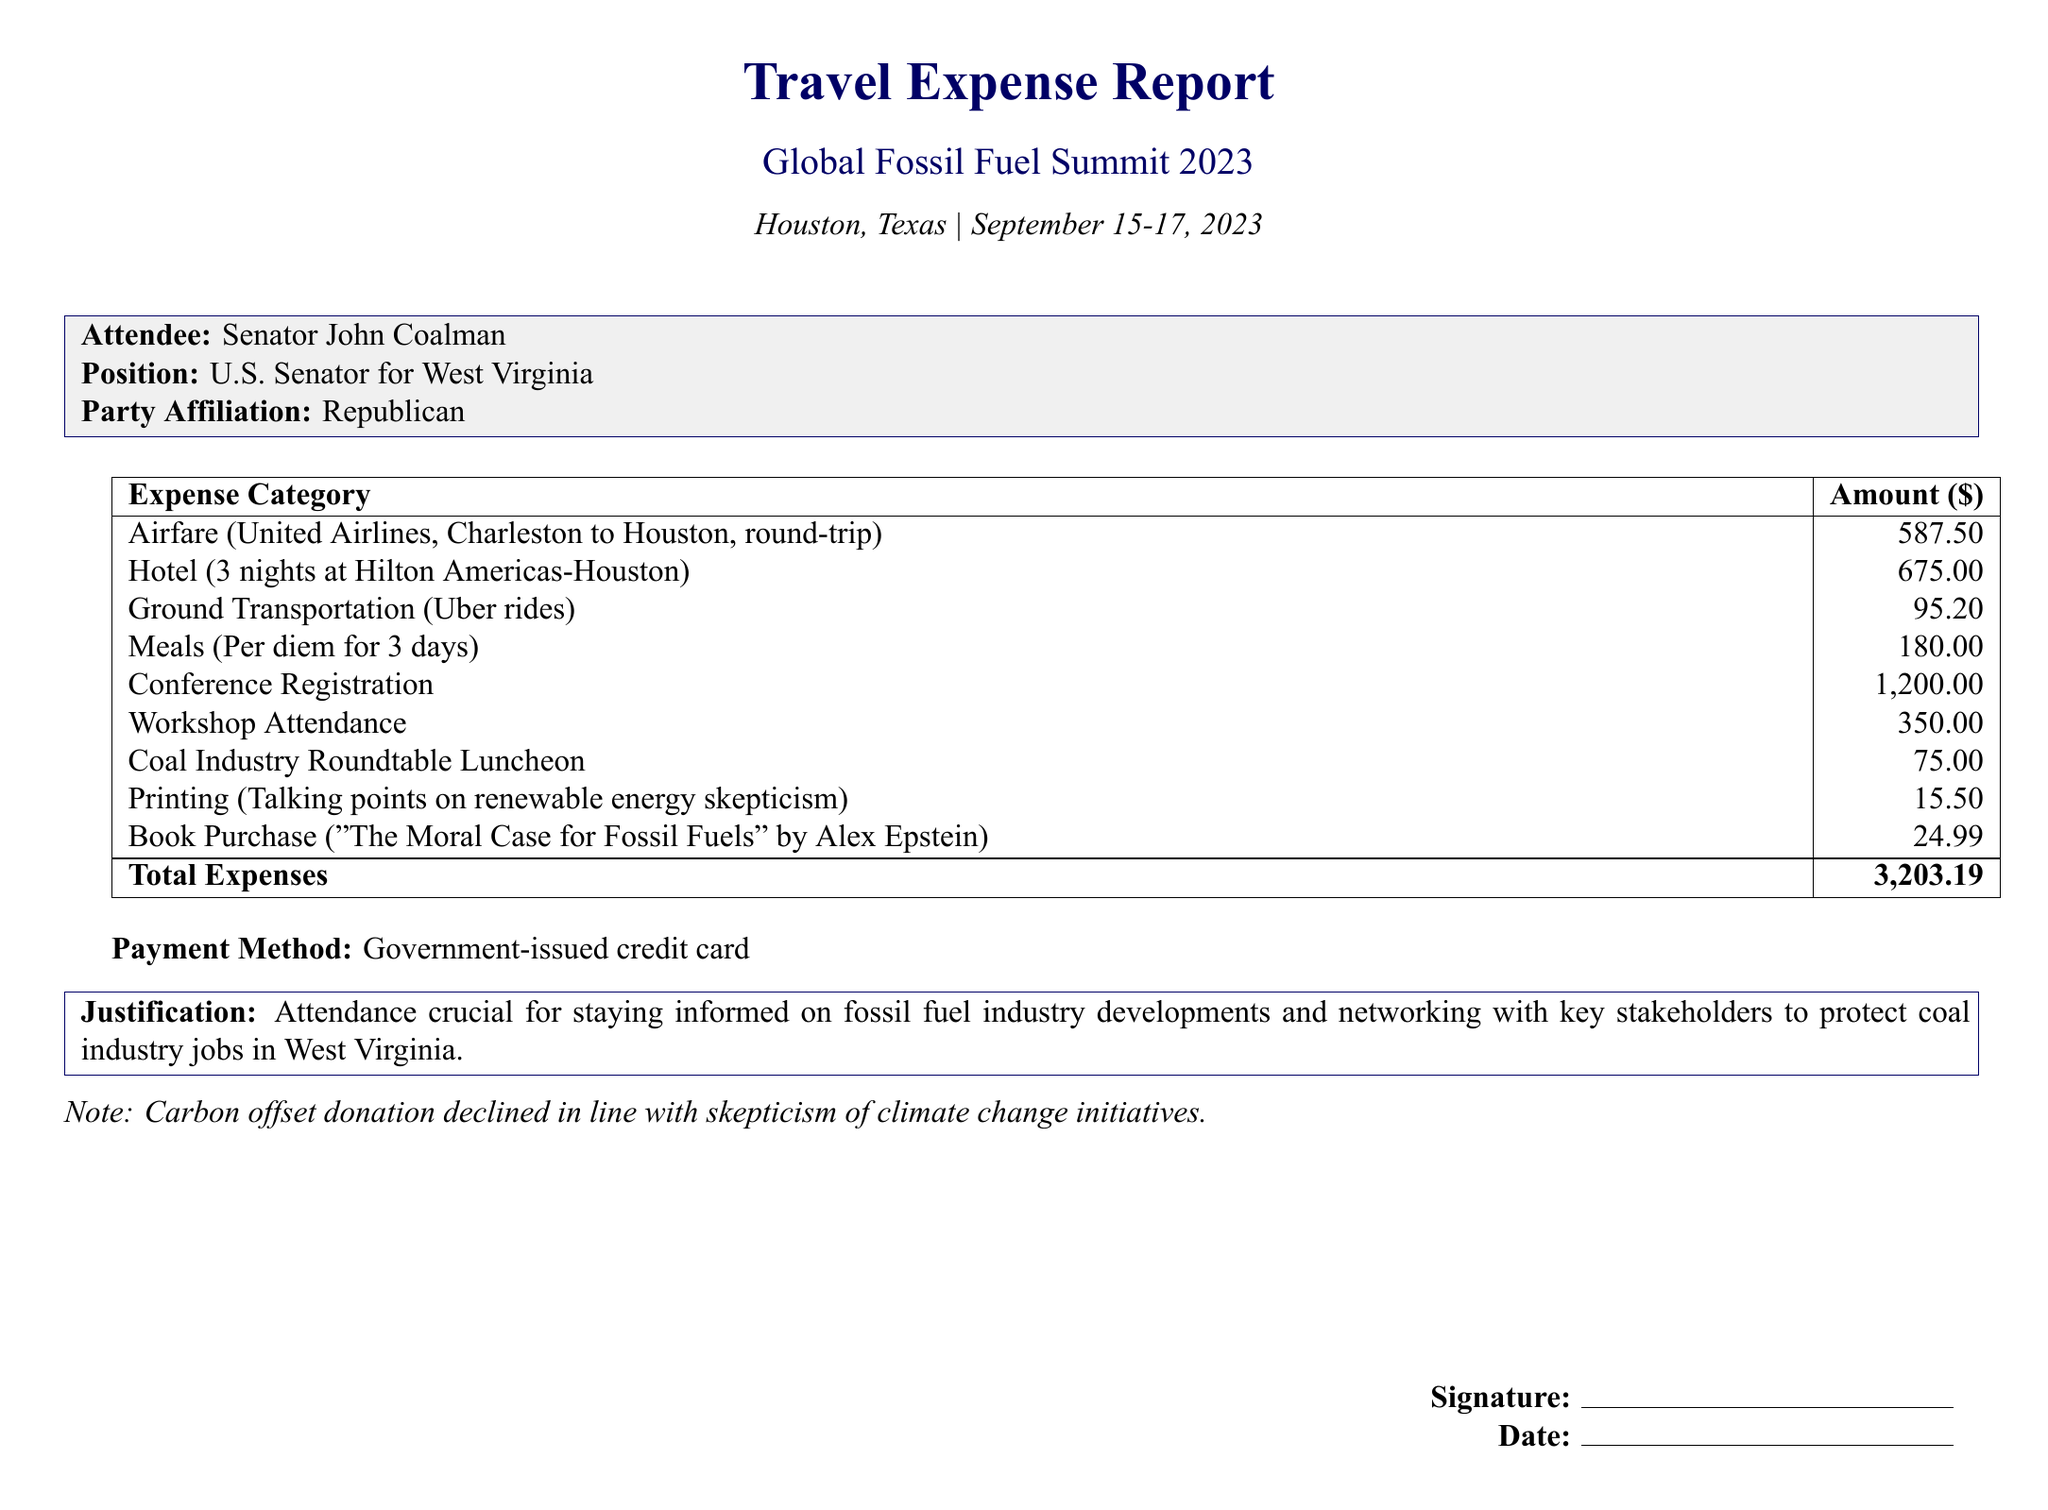What is the name of the conference? The name of the conference is stated in the document as "Global Fossil Fuel Summit 2023."
Answer: Global Fossil Fuel Summit 2023 Where was the conference held? The location of the conference is specified as Houston, Texas.
Answer: Houston, Texas What was the total amount of travel expenses? The total travel expenses are calculated and listed as $3203.19.
Answer: 3203.19 Who is the attendee of the conference? The document specifies that the attendee is Senator John Coalman.
Answer: Senator John Coalman What was the airfare expense? The airfare expense for the round-trip flight is detailed as $587.50.
Answer: 587.50 What type of payment method was used for the expenses? The payment method is indicated as a government-issued credit card.
Answer: Government-issued credit card What was the cost of the Coal Industry Roundtable Luncheon? The cost of the luncheon is itemized in the document as $75.00.
Answer: 75.00 What is the justification for attending the conference? The justification provided emphasizes the importance of networking to protect coal industry jobs.
Answer: Attendance crucial for staying informed on fossil fuel industry developments and networking with key stakeholders to protect coal industry jobs in West Virginia What book was purchased during the trip? The document lists "The Moral Case for Fossil Fuels" by Alex Epstein as the purchased book.
Answer: The Moral Case for Fossil Fuels by Alex Epstein What is noted about the carbon offset donation? The document mentions that the carbon offset donation was declined.
Answer: Declined in line with skepticism of climate change initiatives 